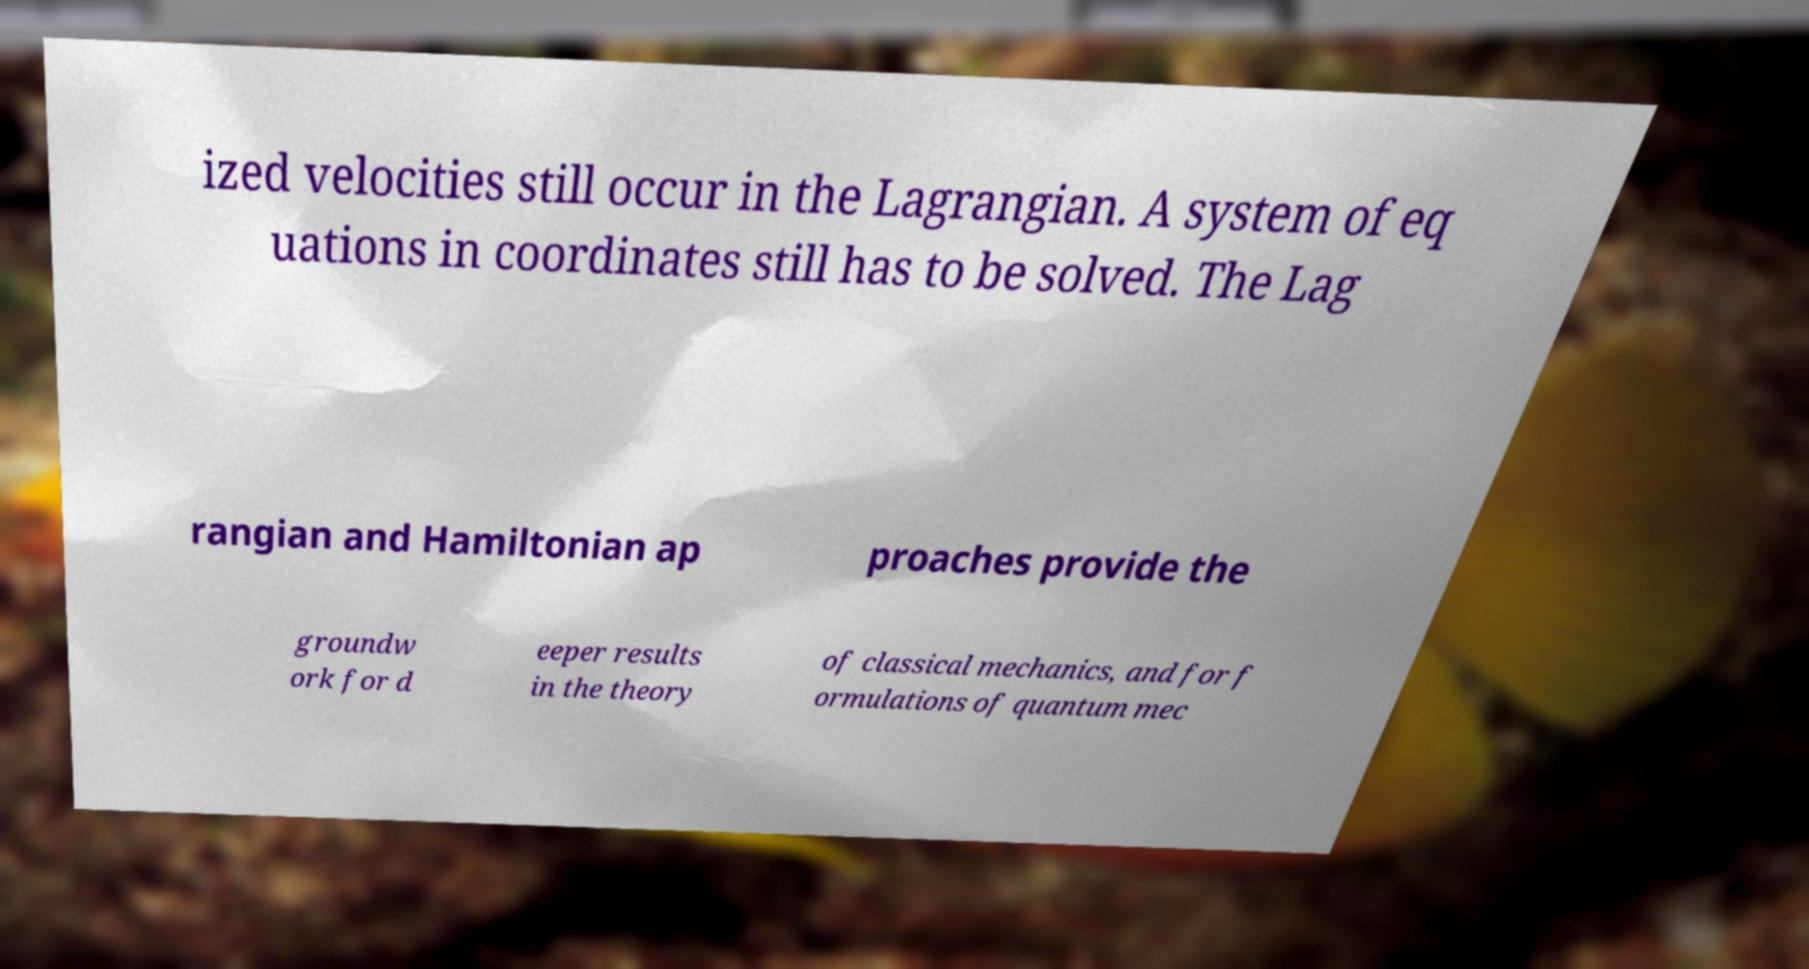Please identify and transcribe the text found in this image. ized velocities still occur in the Lagrangian. A system of eq uations in coordinates still has to be solved. The Lag rangian and Hamiltonian ap proaches provide the groundw ork for d eeper results in the theory of classical mechanics, and for f ormulations of quantum mec 